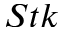Convert formula to latex. <formula><loc_0><loc_0><loc_500><loc_500>S t k</formula> 